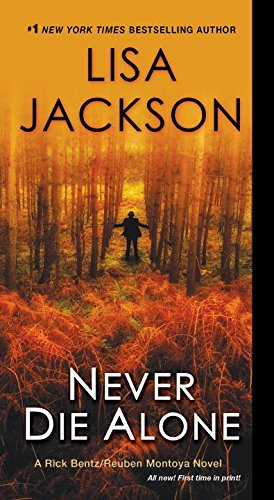Is this book related to Parenting & Relationships? No, this book is not related to Parenting & Relationships. It concentrates on themes of crime and suspense, which are starkly different from the topics usually covered in parenting or relationship guides. 